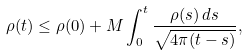Convert formula to latex. <formula><loc_0><loc_0><loc_500><loc_500>\rho ( t ) \leq \rho ( 0 ) + M \int _ { 0 } ^ { t } \frac { \rho ( s ) \, d s } { \sqrt { 4 \pi ( t - s ) } } ,</formula> 